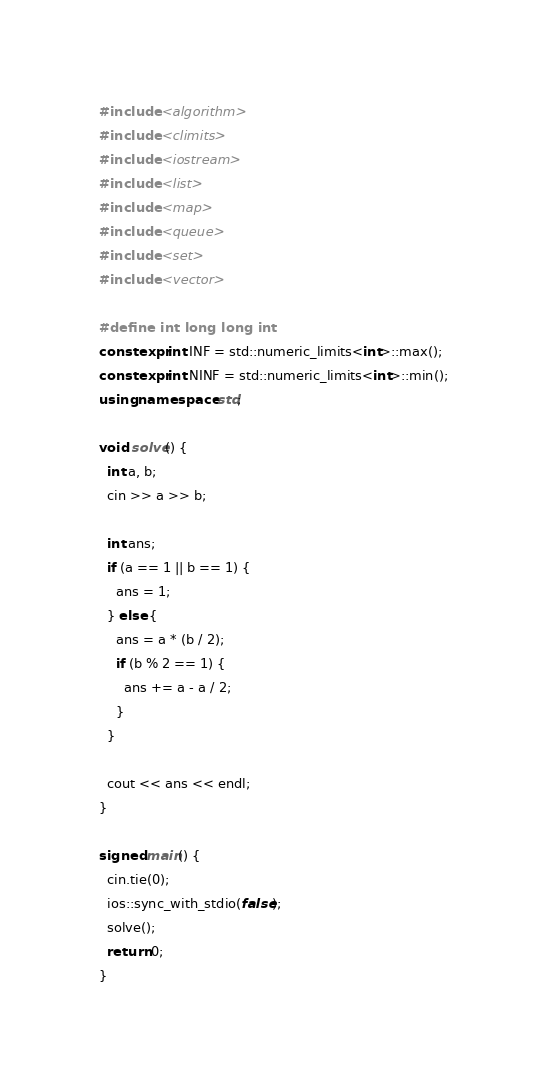Convert code to text. <code><loc_0><loc_0><loc_500><loc_500><_C++_>#include <algorithm>
#include <climits>
#include <iostream>
#include <list>
#include <map>
#include <queue>
#include <set>
#include <vector>

#define int long long int
constexpr int INF = std::numeric_limits<int>::max();
constexpr int NINF = std::numeric_limits<int>::min();
using namespace std;

void solve() {
  int a, b;
  cin >> a >> b;

  int ans;
  if (a == 1 || b == 1) {
    ans = 1;
  } else {
    ans = a * (b / 2);
    if (b % 2 == 1) {
      ans += a - a / 2;
    }
  }

  cout << ans << endl;
}

signed main() {
  cin.tie(0);
  ios::sync_with_stdio(false);
  solve();
  return 0;
}
</code> 